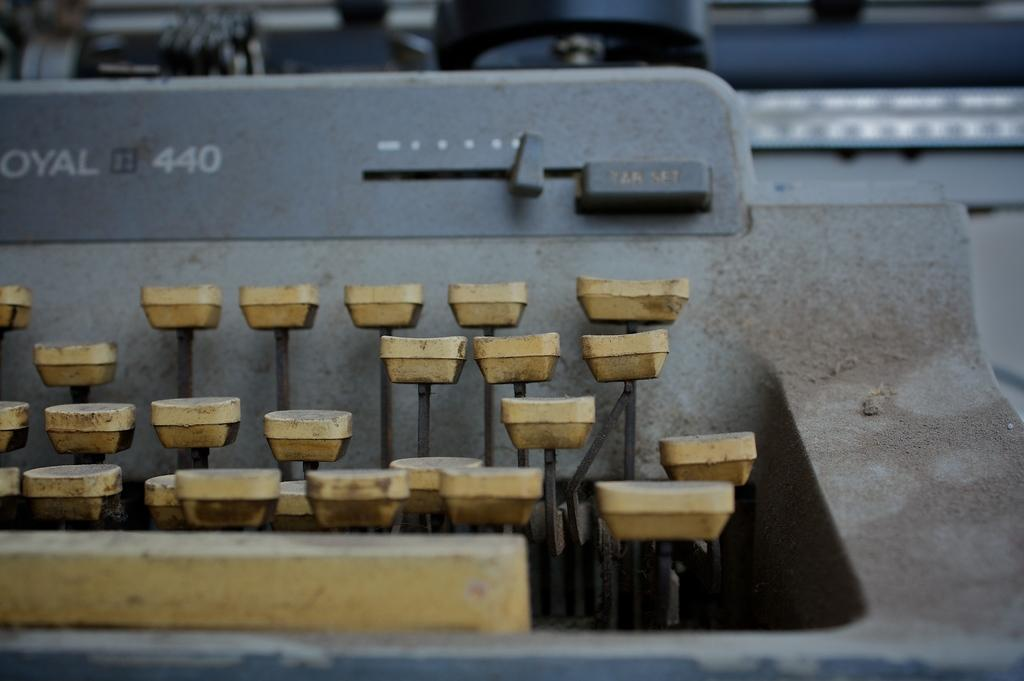<image>
Summarize the visual content of the image. an old dusty typewriter with model number 440 